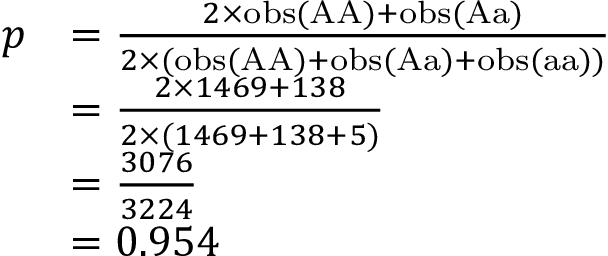Convert formula to latex. <formula><loc_0><loc_0><loc_500><loc_500>{ \begin{array} { r l } { p } & { = { \frac { 2 \times o b s ( { A A } ) + o b s ( { A a } ) } { 2 \times ( o b s ( { A A } ) + o b s ( { A a } ) + o b s ( { a a } ) ) } } } \\ & { = { \frac { 2 \times 1 4 6 9 + 1 3 8 } { 2 \times ( 1 4 6 9 + 1 3 8 + 5 ) } } } \\ & { = { \frac { 3 0 7 6 } { 3 2 2 4 } } } \\ & { = 0 . 9 5 4 } \end{array} }</formula> 